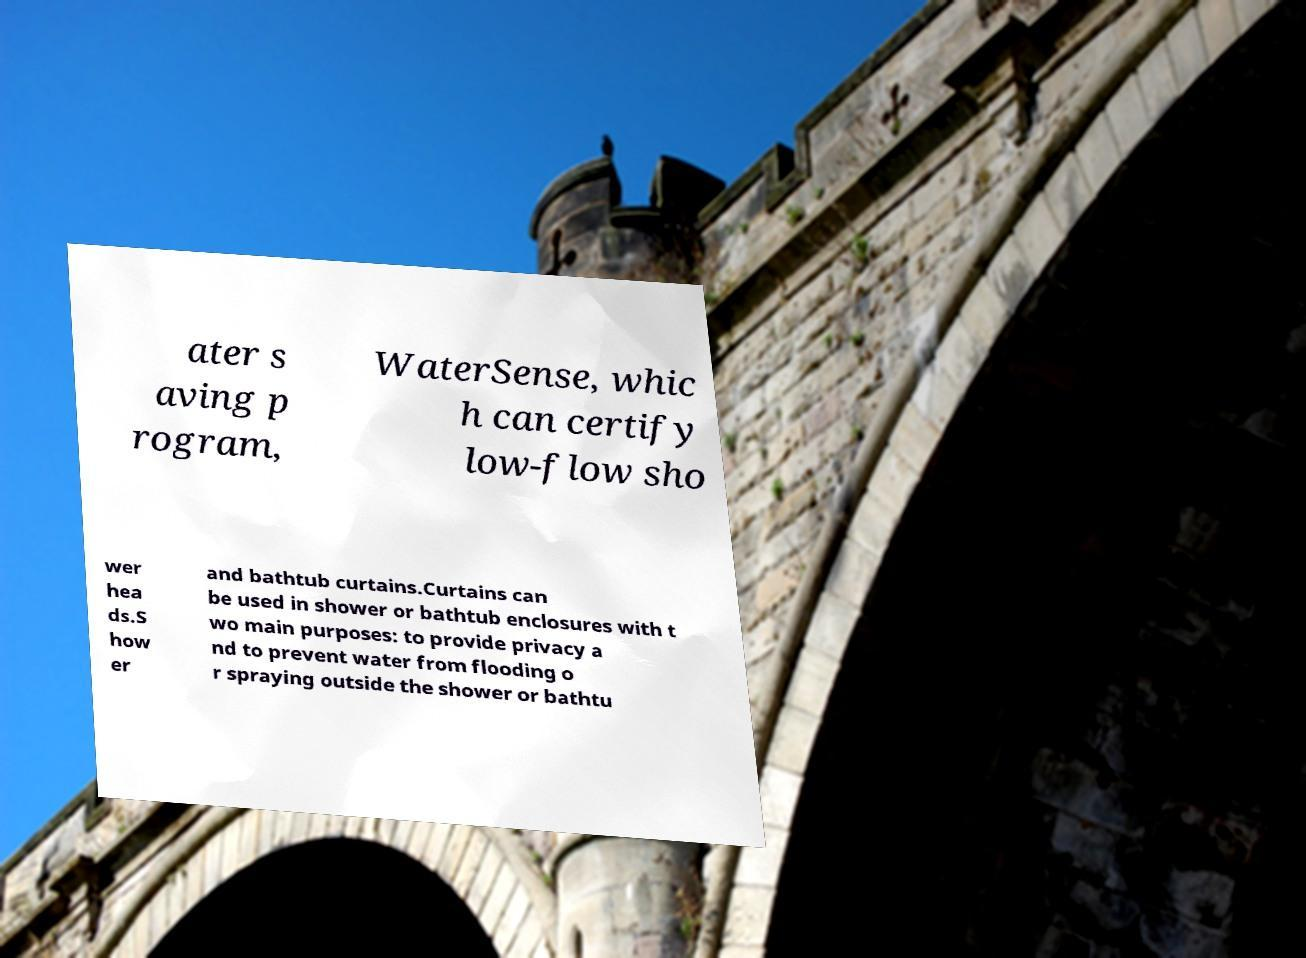What messages or text are displayed in this image? I need them in a readable, typed format. ater s aving p rogram, WaterSense, whic h can certify low-flow sho wer hea ds.S how er and bathtub curtains.Curtains can be used in shower or bathtub enclosures with t wo main purposes: to provide privacy a nd to prevent water from flooding o r spraying outside the shower or bathtu 